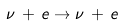Convert formula to latex. <formula><loc_0><loc_0><loc_500><loc_500>\nu \, + \, e \to \nu \, + \, e</formula> 